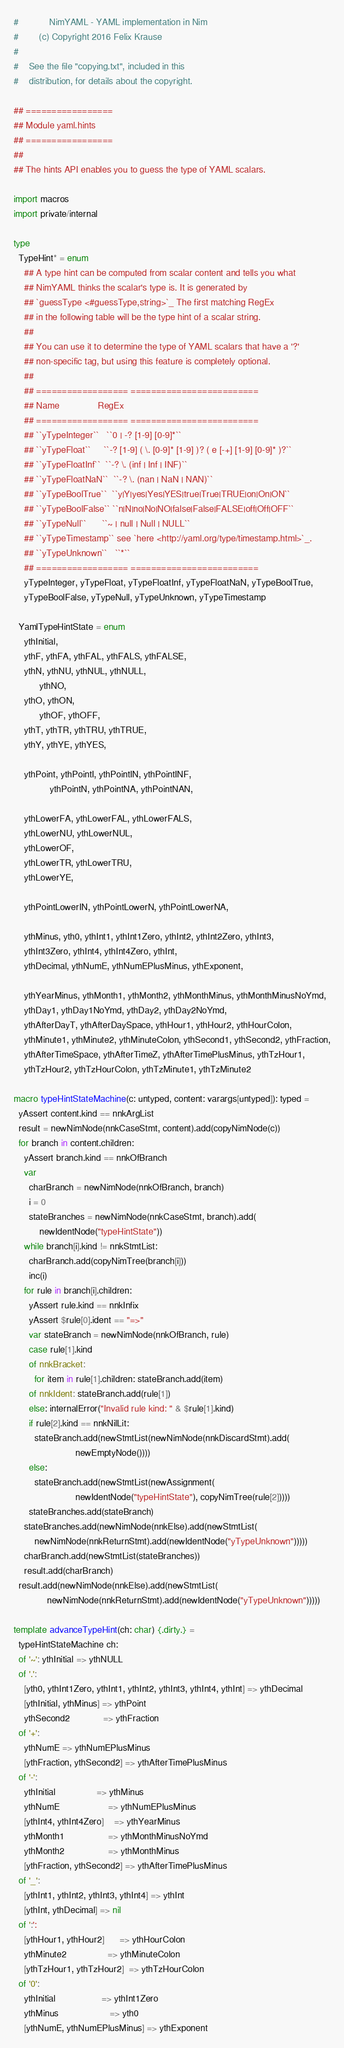<code> <loc_0><loc_0><loc_500><loc_500><_Nim_>#            NimYAML - YAML implementation in Nim
#        (c) Copyright 2016 Felix Krause
#
#    See the file "copying.txt", included in this
#    distribution, for details about the copyright.

## =================
## Module yaml.hints
## =================
##
## The hints API enables you to guess the type of YAML scalars.

import macros
import private/internal

type
  TypeHint* = enum
    ## A type hint can be computed from scalar content and tells you what
    ## NimYAML thinks the scalar's type is. It is generated by
    ## `guessType <#guessType,string>`_ The first matching RegEx
    ## in the following table will be the type hint of a scalar string.
    ##
    ## You can use it to determine the type of YAML scalars that have a '?'
    ## non-specific tag, but using this feature is completely optional.
    ##
    ## ================== =========================
    ## Name               RegEx
    ## ================== =========================
    ## ``yTypeInteger``   ``0 | -? [1-9] [0-9]*``
    ## ``yTypeFloat``     ``-? [1-9] ( \. [0-9]* [1-9] )? ( e [-+] [1-9] [0-9]* )?``
    ## ``yTypeFloatInf``  ``-? \. (inf | Inf | INF)``
    ## ``yTypeFloatNaN``  ``-? \. (nan | NaN | NAN)``
    ## ``yTypeBoolTrue``  ``y|Y|yes|Yes|YES|true|True|TRUE|on|On|ON``
    ## ``yTypeBoolFalse`` ``n|N|no|No|NO|false|False|FALSE|off|Off|OFF``
    ## ``yTypeNull``      ``~ | null | Null | NULL``
    ## ``yTypeTimestamp`` see `here <http://yaml.org/type/timestamp.html>`_.
    ## ``yTypeUnknown``   ``*``
    ## ================== =========================
    yTypeInteger, yTypeFloat, yTypeFloatInf, yTypeFloatNaN, yTypeBoolTrue,
    yTypeBoolFalse, yTypeNull, yTypeUnknown, yTypeTimestamp

  YamlTypeHintState = enum
    ythInitial,
    ythF, ythFA, ythFAL, ythFALS, ythFALSE,
    ythN, ythNU, ythNUL, ythNULL,
          ythNO,
    ythO, ythON,
          ythOF, ythOFF,
    ythT, ythTR, ythTRU, ythTRUE,
    ythY, ythYE, ythYES,

    ythPoint, ythPointI, ythPointIN, ythPointINF,
              ythPointN, ythPointNA, ythPointNAN,

    ythLowerFA, ythLowerFAL, ythLowerFALS,
    ythLowerNU, ythLowerNUL,
    ythLowerOF,
    ythLowerTR, ythLowerTRU,
    ythLowerYE,

    ythPointLowerIN, ythPointLowerN, ythPointLowerNA,

    ythMinus, yth0, ythInt1, ythInt1Zero, ythInt2, ythInt2Zero, ythInt3,
    ythInt3Zero, ythInt4, ythInt4Zero, ythInt,
    ythDecimal, ythNumE, ythNumEPlusMinus, ythExponent,

    ythYearMinus, ythMonth1, ythMonth2, ythMonthMinus, ythMonthMinusNoYmd,
    ythDay1, ythDay1NoYmd, ythDay2, ythDay2NoYmd,
    ythAfterDayT, ythAfterDaySpace, ythHour1, ythHour2, ythHourColon,
    ythMinute1, ythMinute2, ythMinuteColon, ythSecond1, ythSecond2, ythFraction,
    ythAfterTimeSpace, ythAfterTimeZ, ythAfterTimePlusMinus, ythTzHour1,
    ythTzHour2, ythTzHourColon, ythTzMinute1, ythTzMinute2

macro typeHintStateMachine(c: untyped, content: varargs[untyped]): typed =
  yAssert content.kind == nnkArgList
  result = newNimNode(nnkCaseStmt, content).add(copyNimNode(c))
  for branch in content.children:
    yAssert branch.kind == nnkOfBranch
    var
      charBranch = newNimNode(nnkOfBranch, branch)
      i = 0
      stateBranches = newNimNode(nnkCaseStmt, branch).add(
          newIdentNode("typeHintState"))
    while branch[i].kind != nnkStmtList:
      charBranch.add(copyNimTree(branch[i]))
      inc(i)
    for rule in branch[i].children:
      yAssert rule.kind == nnkInfix
      yAssert $rule[0].ident == "=>"
      var stateBranch = newNimNode(nnkOfBranch, rule)
      case rule[1].kind
      of nnkBracket:
        for item in rule[1].children: stateBranch.add(item)
      of nnkIdent: stateBranch.add(rule[1])
      else: internalError("Invalid rule kind: " & $rule[1].kind)
      if rule[2].kind == nnkNilLit:
        stateBranch.add(newStmtList(newNimNode(nnkDiscardStmt).add(
                        newEmptyNode())))
      else:
        stateBranch.add(newStmtList(newAssignment(
                        newIdentNode("typeHintState"), copyNimTree(rule[2]))))
      stateBranches.add(stateBranch)
    stateBranches.add(newNimNode(nnkElse).add(newStmtList(
        newNimNode(nnkReturnStmt).add(newIdentNode("yTypeUnknown")))))
    charBranch.add(newStmtList(stateBranches))
    result.add(charBranch)
  result.add(newNimNode(nnkElse).add(newStmtList(
             newNimNode(nnkReturnStmt).add(newIdentNode("yTypeUnknown")))))

template advanceTypeHint(ch: char) {.dirty.} =
  typeHintStateMachine ch:
  of '~': ythInitial => ythNULL
  of '.':
    [yth0, ythInt1Zero, ythInt1, ythInt2, ythInt3, ythInt4, ythInt] => ythDecimal
    [ythInitial, ythMinus] => ythPoint
    ythSecond2             => ythFraction
  of '+':
    ythNumE => ythNumEPlusMinus
    [ythFraction, ythSecond2] => ythAfterTimePlusMinus
  of '-':
    ythInitial                => ythMinus
    ythNumE                   => ythNumEPlusMinus
    [ythInt4, ythInt4Zero]    => ythYearMinus
    ythMonth1                 => ythMonthMinusNoYmd
    ythMonth2                 => ythMonthMinus
    [ythFraction, ythSecond2] => ythAfterTimePlusMinus
  of '_':
    [ythInt1, ythInt2, ythInt3, ythInt4] => ythInt
    [ythInt, ythDecimal] => nil
  of ':':
    [ythHour1, ythHour2]      => ythHourColon
    ythMinute2                => ythMinuteColon
    [ythTzHour1, ythTzHour2]  => ythTzHourColon
  of '0':
    ythInitial                  => ythInt1Zero
    ythMinus                    => yth0
    [ythNumE, ythNumEPlusMinus] => ythExponent</code> 